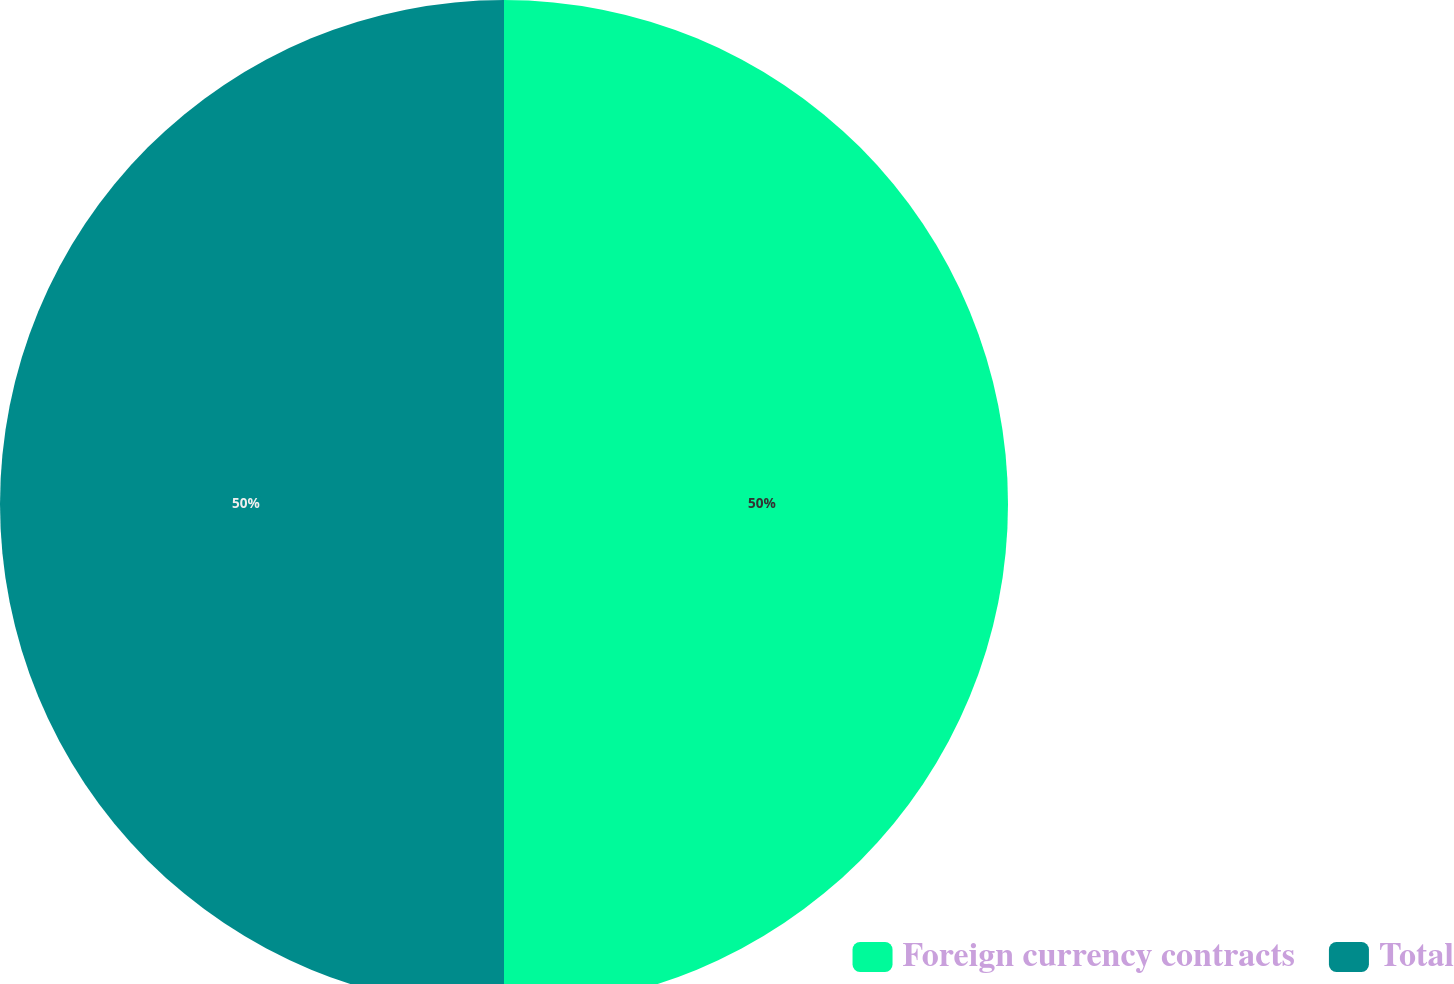Convert chart to OTSL. <chart><loc_0><loc_0><loc_500><loc_500><pie_chart><fcel>Foreign currency contracts<fcel>Total<nl><fcel>50.0%<fcel>50.0%<nl></chart> 